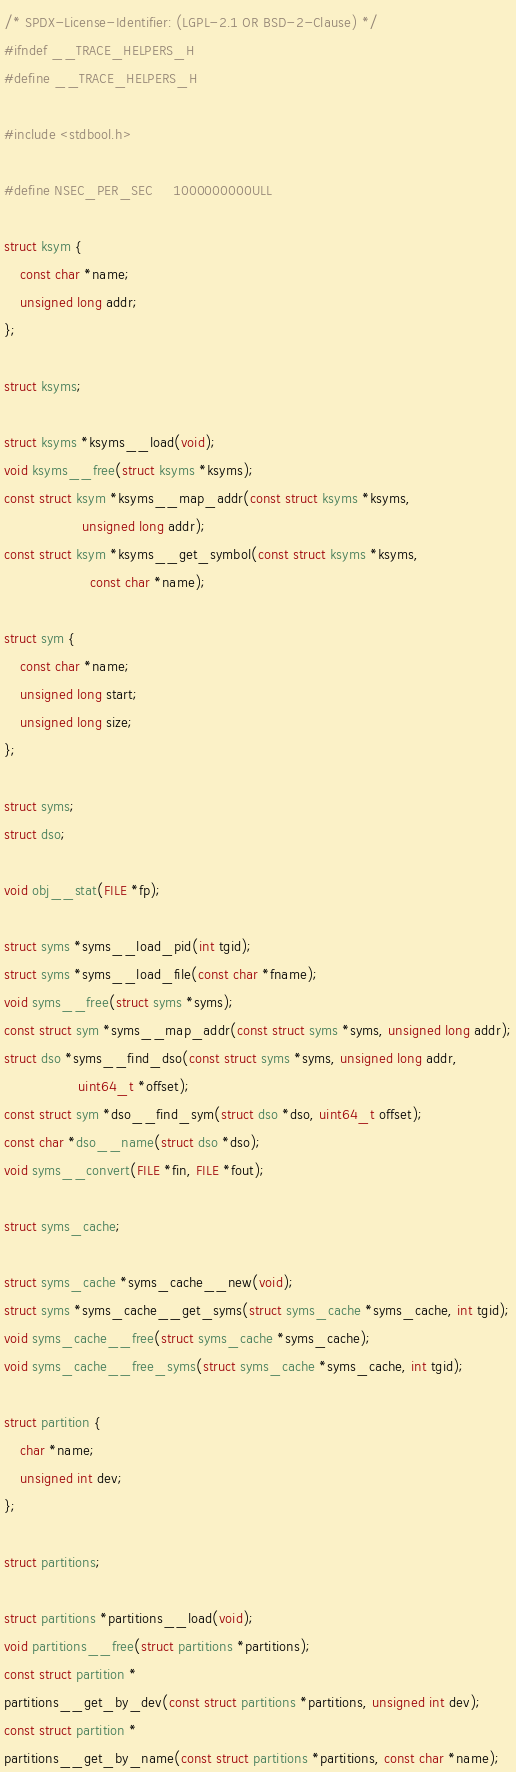Convert code to text. <code><loc_0><loc_0><loc_500><loc_500><_C_>/* SPDX-License-Identifier: (LGPL-2.1 OR BSD-2-Clause) */
#ifndef __TRACE_HELPERS_H
#define __TRACE_HELPERS_H

#include <stdbool.h>

#define NSEC_PER_SEC		1000000000ULL

struct ksym {
	const char *name;
	unsigned long addr;
};

struct ksyms;

struct ksyms *ksyms__load(void);
void ksyms__free(struct ksyms *ksyms);
const struct ksym *ksyms__map_addr(const struct ksyms *ksyms,
				   unsigned long addr);
const struct ksym *ksyms__get_symbol(const struct ksyms *ksyms,
				     const char *name);

struct sym {
	const char *name;
	unsigned long start;
	unsigned long size;
};

struct syms;
struct dso;

void obj__stat(FILE *fp);

struct syms *syms__load_pid(int tgid);
struct syms *syms__load_file(const char *fname);
void syms__free(struct syms *syms);
const struct sym *syms__map_addr(const struct syms *syms, unsigned long addr);
struct dso *syms__find_dso(const struct syms *syms, unsigned long addr,
				  uint64_t *offset);
const struct sym *dso__find_sym(struct dso *dso, uint64_t offset);
const char *dso__name(struct dso *dso);
void syms__convert(FILE *fin, FILE *fout);

struct syms_cache;

struct syms_cache *syms_cache__new(void);
struct syms *syms_cache__get_syms(struct syms_cache *syms_cache, int tgid);
void syms_cache__free(struct syms_cache *syms_cache);
void syms_cache__free_syms(struct syms_cache *syms_cache, int tgid);

struct partition {
	char *name;
	unsigned int dev;
};

struct partitions;

struct partitions *partitions__load(void);
void partitions__free(struct partitions *partitions);
const struct partition *
partitions__get_by_dev(const struct partitions *partitions, unsigned int dev);
const struct partition *
partitions__get_by_name(const struct partitions *partitions, const char *name);
</code> 